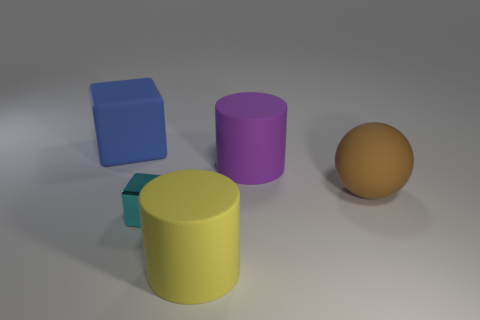What number of other objects are the same color as the tiny block?
Your answer should be compact. 0. What is the large sphere made of?
Your response must be concise. Rubber. The large object that is right of the big yellow cylinder and behind the brown ball is made of what material?
Make the answer very short. Rubber. What number of objects are large things that are behind the purple matte cylinder or rubber balls?
Keep it short and to the point. 2. Do the small metal thing and the big block have the same color?
Your response must be concise. No. Is there a cylinder that has the same size as the matte cube?
Give a very brief answer. Yes. How many rubber objects are both behind the big yellow thing and in front of the large blue matte object?
Your answer should be very brief. 2. There is a small cyan metal thing; how many big things are to the right of it?
Offer a very short reply. 3. Are there any large brown things of the same shape as the big purple matte thing?
Offer a terse response. No. Does the yellow rubber object have the same shape as the big rubber thing that is left of the small cyan block?
Your answer should be very brief. No. 